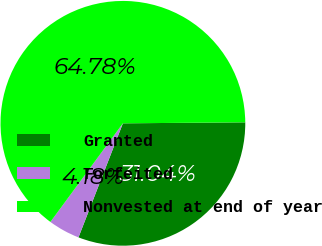Convert chart to OTSL. <chart><loc_0><loc_0><loc_500><loc_500><pie_chart><fcel>Granted<fcel>Forfeited<fcel>Nonvested at end of year<nl><fcel>31.04%<fcel>4.18%<fcel>64.78%<nl></chart> 